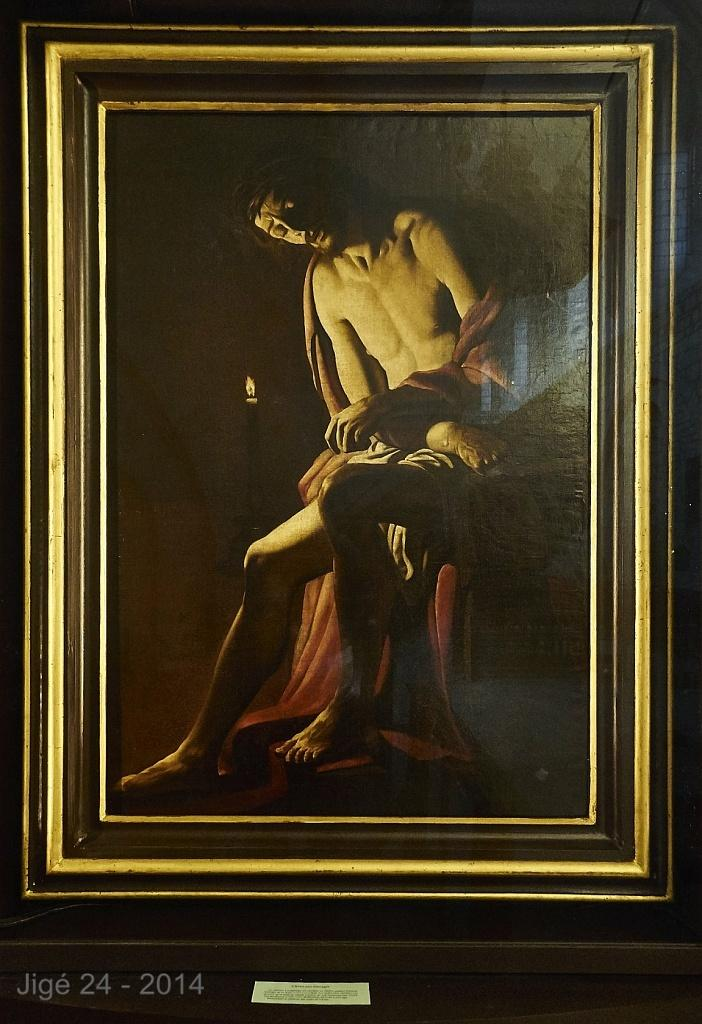<image>
Share a concise interpretation of the image provided. A framed painting of an undressed man draped in some cloth with the date under the frame of the year 2014. 